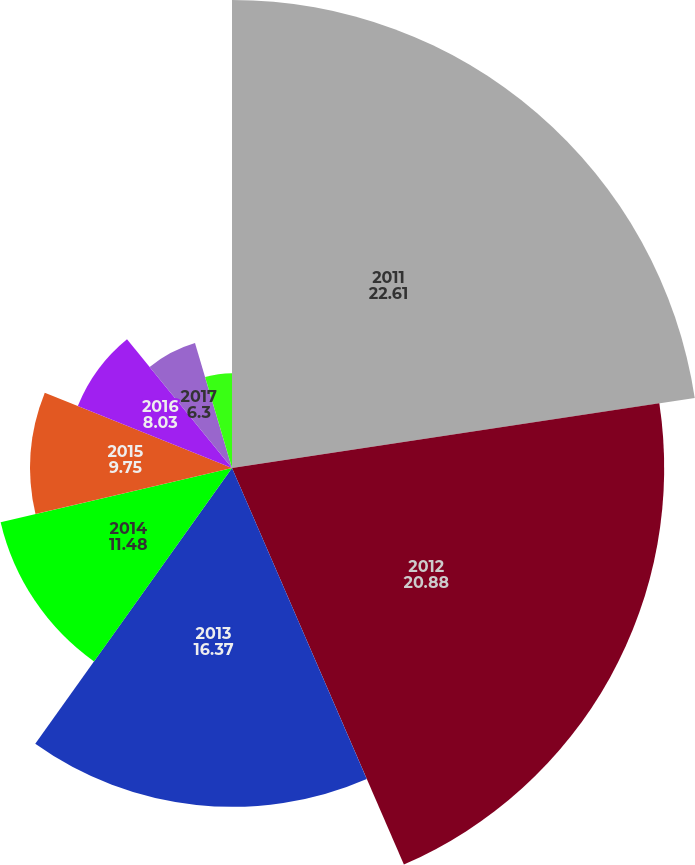<chart> <loc_0><loc_0><loc_500><loc_500><pie_chart><fcel>2011<fcel>2012<fcel>2013<fcel>2014<fcel>2015<fcel>2016<fcel>2017<fcel>2018<nl><fcel>22.61%<fcel>20.88%<fcel>16.37%<fcel>11.48%<fcel>9.75%<fcel>8.03%<fcel>6.3%<fcel>4.58%<nl></chart> 